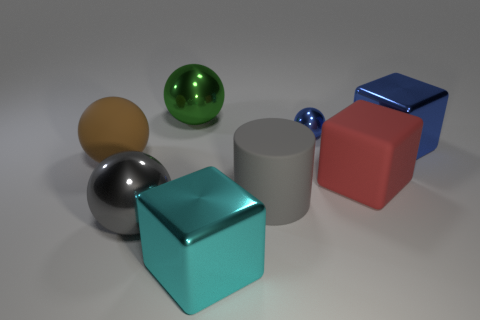Add 1 metallic spheres. How many objects exist? 9 Subtract all blocks. How many objects are left? 5 Subtract all big gray matte objects. Subtract all brown rubber balls. How many objects are left? 6 Add 8 red things. How many red things are left? 9 Add 8 rubber blocks. How many rubber blocks exist? 9 Subtract 0 cyan cylinders. How many objects are left? 8 